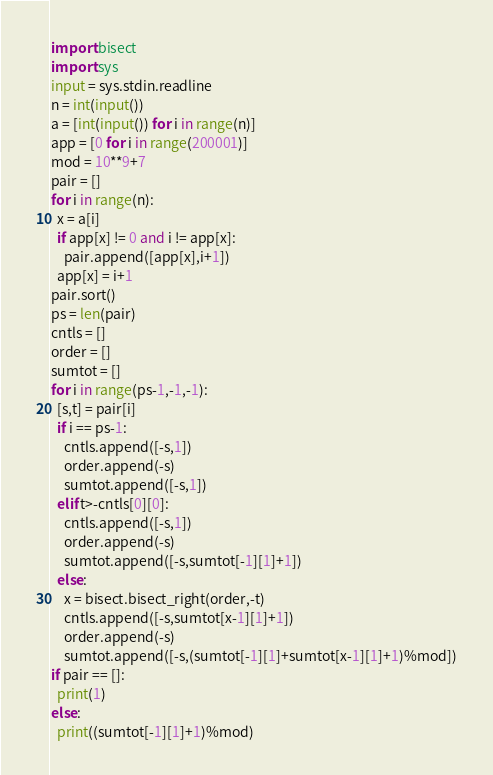<code> <loc_0><loc_0><loc_500><loc_500><_Python_>import bisect
import sys
input = sys.stdin.readline
n = int(input())
a = [int(input()) for i in range(n)]
app = [0 for i in range(200001)]
mod = 10**9+7
pair = []
for i in range(n):
  x = a[i]
  if app[x] != 0 and i != app[x]:
    pair.append([app[x],i+1])
  app[x] = i+1
pair.sort()
ps = len(pair)
cntls = []
order = []
sumtot = []
for i in range(ps-1,-1,-1):
  [s,t] = pair[i]
  if i == ps-1:
    cntls.append([-s,1])
    order.append(-s)
    sumtot.append([-s,1])
  elif t>-cntls[0][0]:
    cntls.append([-s,1])
    order.append(-s)
    sumtot.append([-s,sumtot[-1][1]+1])
  else:
    x = bisect.bisect_right(order,-t)
    cntls.append([-s,sumtot[x-1][1]+1])
    order.append(-s)
    sumtot.append([-s,(sumtot[-1][1]+sumtot[x-1][1]+1)%mod])
if pair == []:
  print(1)
else:
  print((sumtot[-1][1]+1)%mod)</code> 